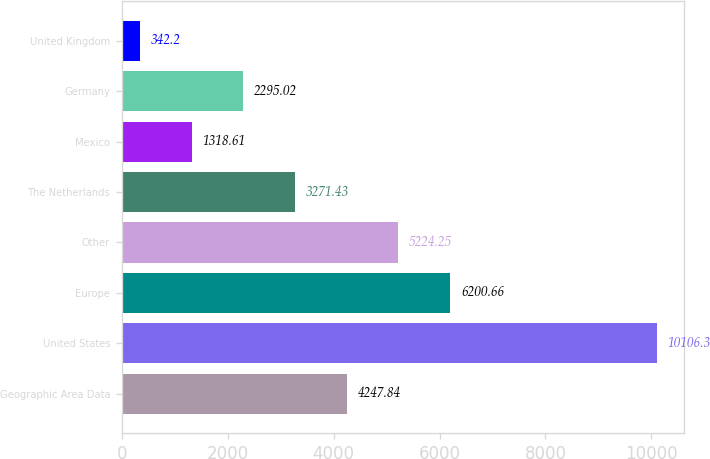Convert chart to OTSL. <chart><loc_0><loc_0><loc_500><loc_500><bar_chart><fcel>Geographic Area Data<fcel>United States<fcel>Europe<fcel>Other<fcel>The Netherlands<fcel>Mexico<fcel>Germany<fcel>United Kingdom<nl><fcel>4247.84<fcel>10106.3<fcel>6200.66<fcel>5224.25<fcel>3271.43<fcel>1318.61<fcel>2295.02<fcel>342.2<nl></chart> 